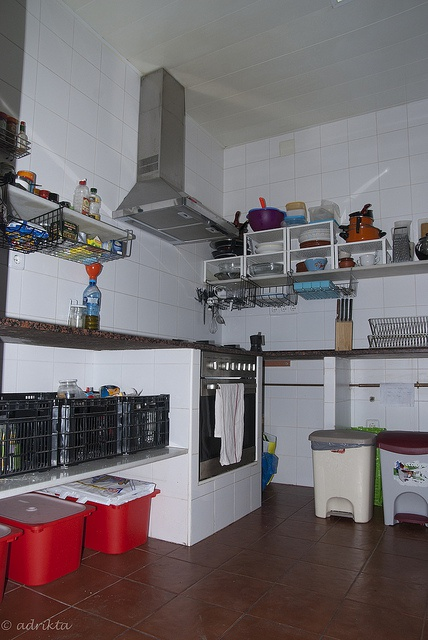Describe the objects in this image and their specific colors. I can see oven in black, darkgray, gray, and lightgray tones, bottle in black, gray, and darkgray tones, bowl in black, purple, and navy tones, bottle in black, darkgray, gray, and maroon tones, and bowl in black, gray, and purple tones in this image. 